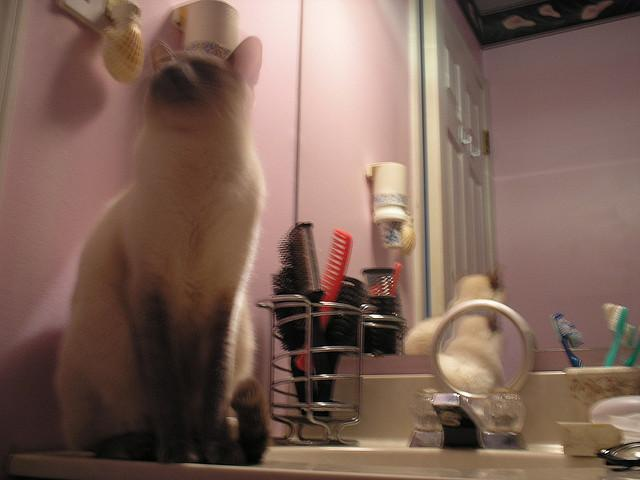What is the red item inside the holder?

Choices:
A) comb
B) floss
C) razor
D) toothbrush comb 